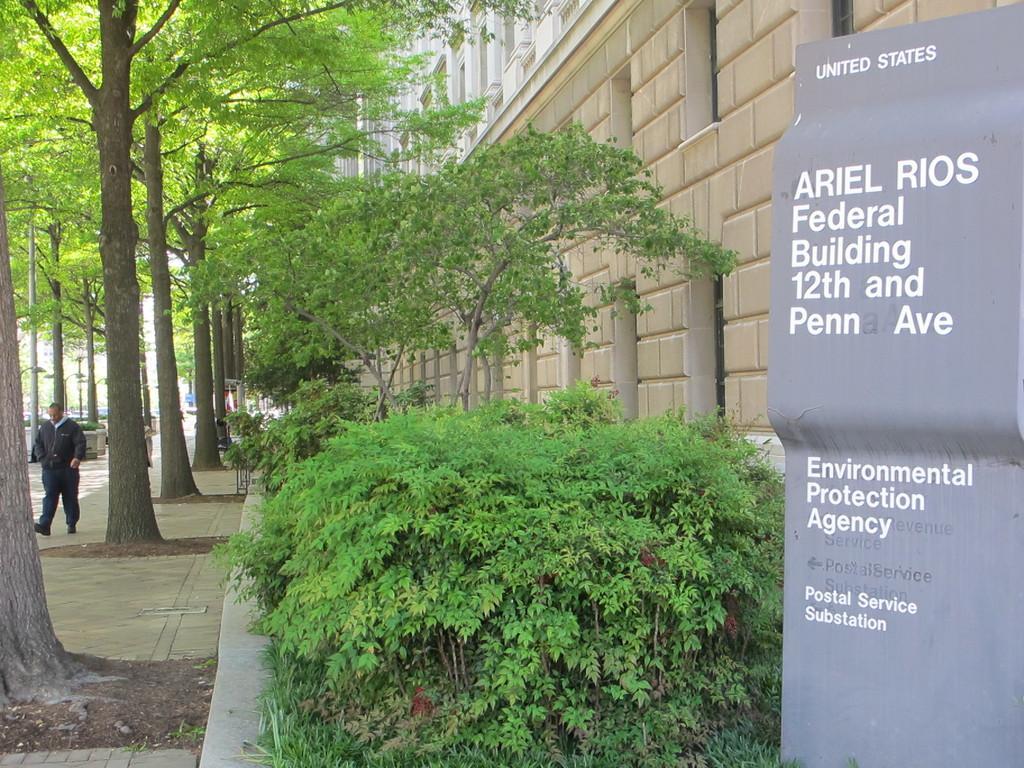Please provide a concise description of this image. In this image we can see a building with windows and a board with some text on it. We can also see some plants, the bark of a tree, a person walking on the pathway, a group of trees and a pole. 